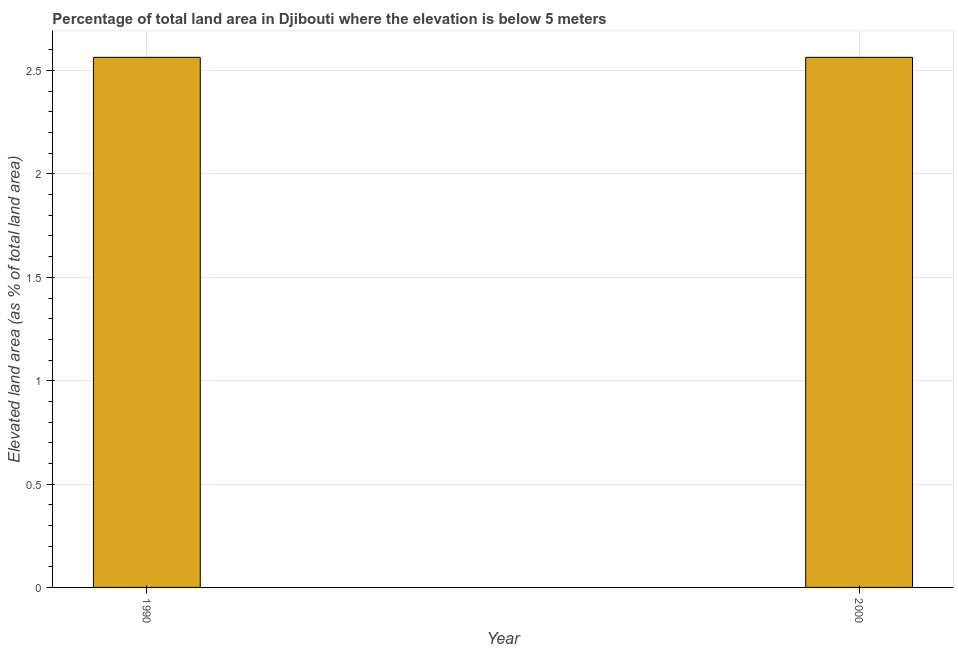Does the graph contain grids?
Your answer should be compact. Yes. What is the title of the graph?
Ensure brevity in your answer.  Percentage of total land area in Djibouti where the elevation is below 5 meters. What is the label or title of the X-axis?
Offer a terse response. Year. What is the label or title of the Y-axis?
Offer a very short reply. Elevated land area (as % of total land area). What is the total elevated land area in 2000?
Provide a succinct answer. 2.56. Across all years, what is the maximum total elevated land area?
Offer a terse response. 2.56. Across all years, what is the minimum total elevated land area?
Your answer should be very brief. 2.56. In which year was the total elevated land area maximum?
Provide a short and direct response. 1990. What is the sum of the total elevated land area?
Your answer should be very brief. 5.13. What is the difference between the total elevated land area in 1990 and 2000?
Your answer should be very brief. 0. What is the average total elevated land area per year?
Provide a short and direct response. 2.56. What is the median total elevated land area?
Keep it short and to the point. 2.56. What is the ratio of the total elevated land area in 1990 to that in 2000?
Ensure brevity in your answer.  1. Is the total elevated land area in 1990 less than that in 2000?
Give a very brief answer. No. In how many years, is the total elevated land area greater than the average total elevated land area taken over all years?
Your response must be concise. 0. Are all the bars in the graph horizontal?
Your response must be concise. No. Are the values on the major ticks of Y-axis written in scientific E-notation?
Give a very brief answer. No. What is the Elevated land area (as % of total land area) of 1990?
Your answer should be very brief. 2.56. What is the Elevated land area (as % of total land area) in 2000?
Provide a succinct answer. 2.56. What is the difference between the Elevated land area (as % of total land area) in 1990 and 2000?
Give a very brief answer. 0. 